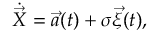<formula> <loc_0><loc_0><loc_500><loc_500>\dot { \vec { X } } = \vec { a } ( t ) + \sigma \vec { \xi } ( t ) ,</formula> 